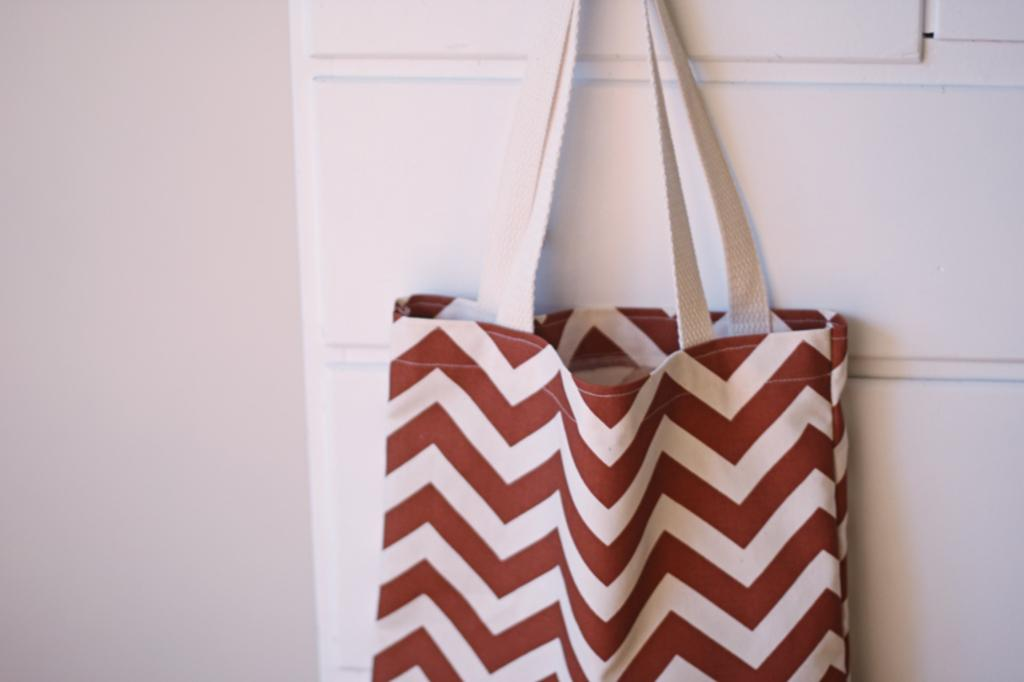What is the color of the bag in the image? The bag in the image is red and white. Where is the bag located in the image? The bag is hanging on a wall. What is the grade of the alley where the bag is located in the image? There is no alley present in the image, so it is not possible to determine the grade of the alley. 